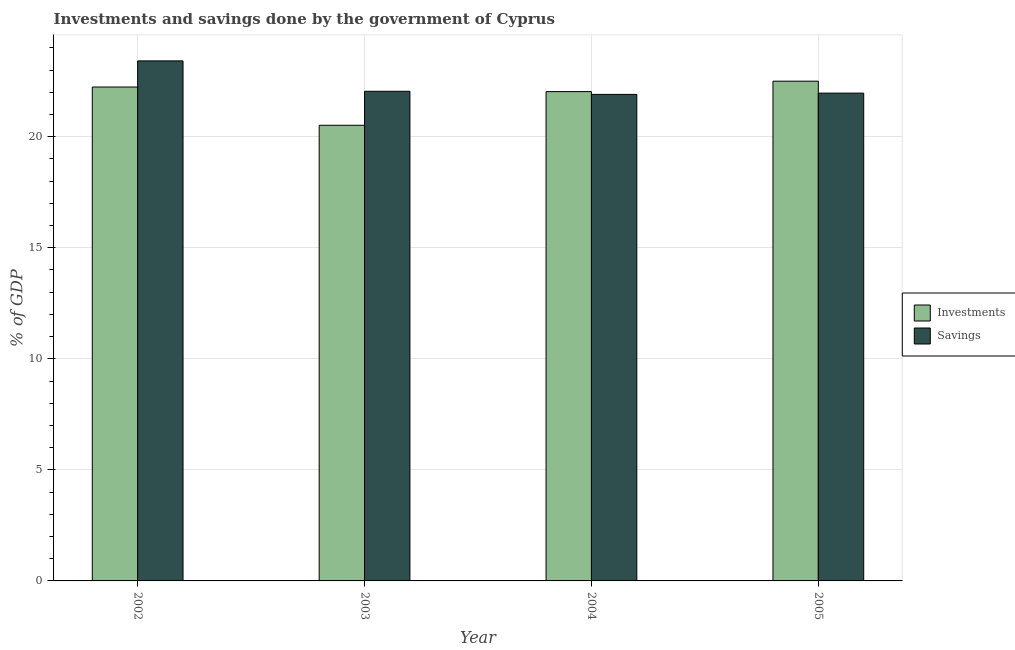Are the number of bars per tick equal to the number of legend labels?
Your response must be concise. Yes. Are the number of bars on each tick of the X-axis equal?
Ensure brevity in your answer.  Yes. What is the savings of government in 2004?
Make the answer very short. 21.91. Across all years, what is the maximum savings of government?
Ensure brevity in your answer.  23.41. Across all years, what is the minimum savings of government?
Provide a short and direct response. 21.91. In which year was the investments of government maximum?
Provide a short and direct response. 2005. In which year was the investments of government minimum?
Make the answer very short. 2003. What is the total investments of government in the graph?
Ensure brevity in your answer.  87.28. What is the difference between the investments of government in 2004 and that in 2005?
Provide a succinct answer. -0.47. What is the difference between the savings of government in 2005 and the investments of government in 2002?
Ensure brevity in your answer.  -1.45. What is the average investments of government per year?
Provide a succinct answer. 21.82. In the year 2003, what is the difference between the savings of government and investments of government?
Ensure brevity in your answer.  0. In how many years, is the investments of government greater than 19 %?
Give a very brief answer. 4. What is the ratio of the investments of government in 2004 to that in 2005?
Give a very brief answer. 0.98. Is the difference between the investments of government in 2002 and 2005 greater than the difference between the savings of government in 2002 and 2005?
Provide a short and direct response. No. What is the difference between the highest and the second highest savings of government?
Offer a terse response. 1.37. What is the difference between the highest and the lowest savings of government?
Make the answer very short. 1.51. What does the 1st bar from the left in 2002 represents?
Your response must be concise. Investments. What does the 1st bar from the right in 2003 represents?
Make the answer very short. Savings. What is the difference between two consecutive major ticks on the Y-axis?
Offer a very short reply. 5. Are the values on the major ticks of Y-axis written in scientific E-notation?
Your response must be concise. No. Does the graph contain any zero values?
Ensure brevity in your answer.  No. Does the graph contain grids?
Your answer should be very brief. Yes. Where does the legend appear in the graph?
Provide a succinct answer. Center right. How many legend labels are there?
Keep it short and to the point. 2. How are the legend labels stacked?
Provide a succinct answer. Vertical. What is the title of the graph?
Your answer should be very brief. Investments and savings done by the government of Cyprus. Does "Excluding technical cooperation" appear as one of the legend labels in the graph?
Ensure brevity in your answer.  No. What is the label or title of the Y-axis?
Provide a short and direct response. % of GDP. What is the % of GDP in Investments in 2002?
Your response must be concise. 22.24. What is the % of GDP in Savings in 2002?
Offer a very short reply. 23.41. What is the % of GDP of Investments in 2003?
Give a very brief answer. 20.51. What is the % of GDP in Savings in 2003?
Offer a terse response. 22.05. What is the % of GDP of Investments in 2004?
Offer a very short reply. 22.03. What is the % of GDP in Savings in 2004?
Provide a short and direct response. 21.91. What is the % of GDP in Investments in 2005?
Your response must be concise. 22.5. What is the % of GDP of Savings in 2005?
Keep it short and to the point. 21.96. Across all years, what is the maximum % of GDP of Investments?
Provide a short and direct response. 22.5. Across all years, what is the maximum % of GDP of Savings?
Give a very brief answer. 23.41. Across all years, what is the minimum % of GDP of Investments?
Make the answer very short. 20.51. Across all years, what is the minimum % of GDP in Savings?
Your answer should be very brief. 21.91. What is the total % of GDP of Investments in the graph?
Keep it short and to the point. 87.28. What is the total % of GDP of Savings in the graph?
Give a very brief answer. 89.33. What is the difference between the % of GDP of Investments in 2002 and that in 2003?
Ensure brevity in your answer.  1.72. What is the difference between the % of GDP in Savings in 2002 and that in 2003?
Ensure brevity in your answer.  1.37. What is the difference between the % of GDP of Investments in 2002 and that in 2004?
Provide a short and direct response. 0.21. What is the difference between the % of GDP of Savings in 2002 and that in 2004?
Ensure brevity in your answer.  1.51. What is the difference between the % of GDP of Investments in 2002 and that in 2005?
Ensure brevity in your answer.  -0.26. What is the difference between the % of GDP in Savings in 2002 and that in 2005?
Your response must be concise. 1.45. What is the difference between the % of GDP in Investments in 2003 and that in 2004?
Offer a very short reply. -1.52. What is the difference between the % of GDP of Savings in 2003 and that in 2004?
Provide a succinct answer. 0.14. What is the difference between the % of GDP in Investments in 2003 and that in 2005?
Your answer should be compact. -1.99. What is the difference between the % of GDP in Savings in 2003 and that in 2005?
Your answer should be very brief. 0.08. What is the difference between the % of GDP of Investments in 2004 and that in 2005?
Keep it short and to the point. -0.47. What is the difference between the % of GDP of Savings in 2004 and that in 2005?
Give a very brief answer. -0.06. What is the difference between the % of GDP of Investments in 2002 and the % of GDP of Savings in 2003?
Make the answer very short. 0.19. What is the difference between the % of GDP of Investments in 2002 and the % of GDP of Savings in 2004?
Offer a terse response. 0.33. What is the difference between the % of GDP of Investments in 2002 and the % of GDP of Savings in 2005?
Your response must be concise. 0.28. What is the difference between the % of GDP in Investments in 2003 and the % of GDP in Savings in 2004?
Your answer should be compact. -1.39. What is the difference between the % of GDP in Investments in 2003 and the % of GDP in Savings in 2005?
Keep it short and to the point. -1.45. What is the difference between the % of GDP in Investments in 2004 and the % of GDP in Savings in 2005?
Ensure brevity in your answer.  0.07. What is the average % of GDP of Investments per year?
Provide a short and direct response. 21.82. What is the average % of GDP of Savings per year?
Your answer should be very brief. 22.33. In the year 2002, what is the difference between the % of GDP of Investments and % of GDP of Savings?
Ensure brevity in your answer.  -1.18. In the year 2003, what is the difference between the % of GDP in Investments and % of GDP in Savings?
Give a very brief answer. -1.53. In the year 2004, what is the difference between the % of GDP in Investments and % of GDP in Savings?
Provide a short and direct response. 0.13. In the year 2005, what is the difference between the % of GDP in Investments and % of GDP in Savings?
Offer a very short reply. 0.54. What is the ratio of the % of GDP in Investments in 2002 to that in 2003?
Make the answer very short. 1.08. What is the ratio of the % of GDP in Savings in 2002 to that in 2003?
Keep it short and to the point. 1.06. What is the ratio of the % of GDP of Investments in 2002 to that in 2004?
Your response must be concise. 1.01. What is the ratio of the % of GDP in Savings in 2002 to that in 2004?
Your answer should be compact. 1.07. What is the ratio of the % of GDP of Investments in 2002 to that in 2005?
Offer a terse response. 0.99. What is the ratio of the % of GDP of Savings in 2002 to that in 2005?
Your response must be concise. 1.07. What is the ratio of the % of GDP of Investments in 2003 to that in 2004?
Keep it short and to the point. 0.93. What is the ratio of the % of GDP in Savings in 2003 to that in 2004?
Ensure brevity in your answer.  1.01. What is the ratio of the % of GDP in Investments in 2003 to that in 2005?
Provide a short and direct response. 0.91. What is the ratio of the % of GDP of Investments in 2004 to that in 2005?
Offer a terse response. 0.98. What is the ratio of the % of GDP of Savings in 2004 to that in 2005?
Offer a very short reply. 1. What is the difference between the highest and the second highest % of GDP in Investments?
Your answer should be compact. 0.26. What is the difference between the highest and the second highest % of GDP of Savings?
Your answer should be compact. 1.37. What is the difference between the highest and the lowest % of GDP in Investments?
Provide a short and direct response. 1.99. What is the difference between the highest and the lowest % of GDP of Savings?
Provide a succinct answer. 1.51. 